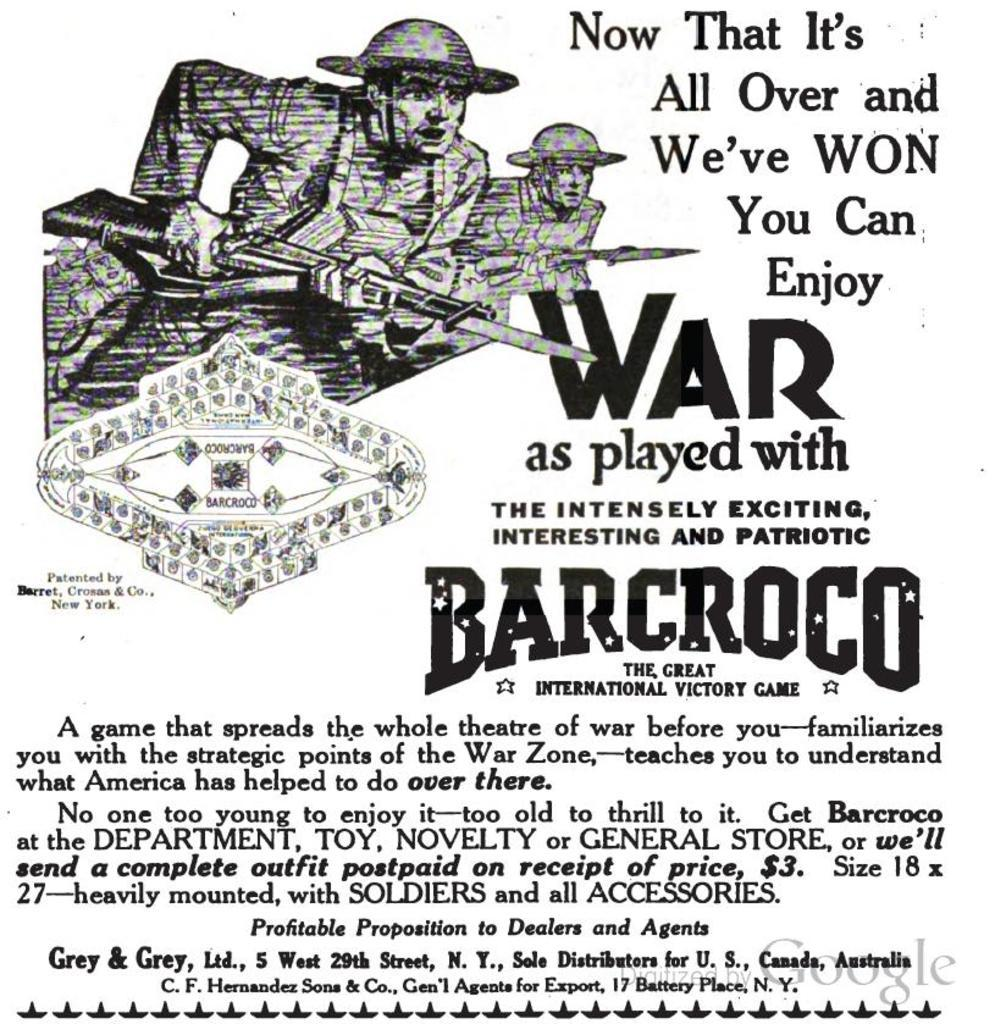<image>
Summarize the visual content of the image. An advertisement for a production called War as played with barocroco. 